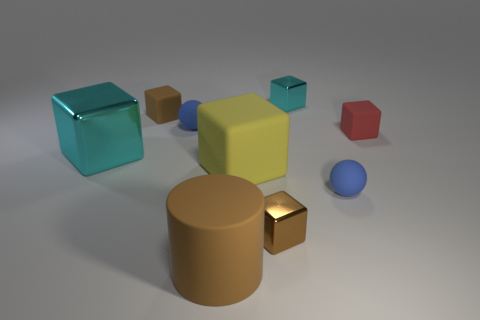There is a small cyan thing that is the same shape as the large metal object; what is its material? metal 